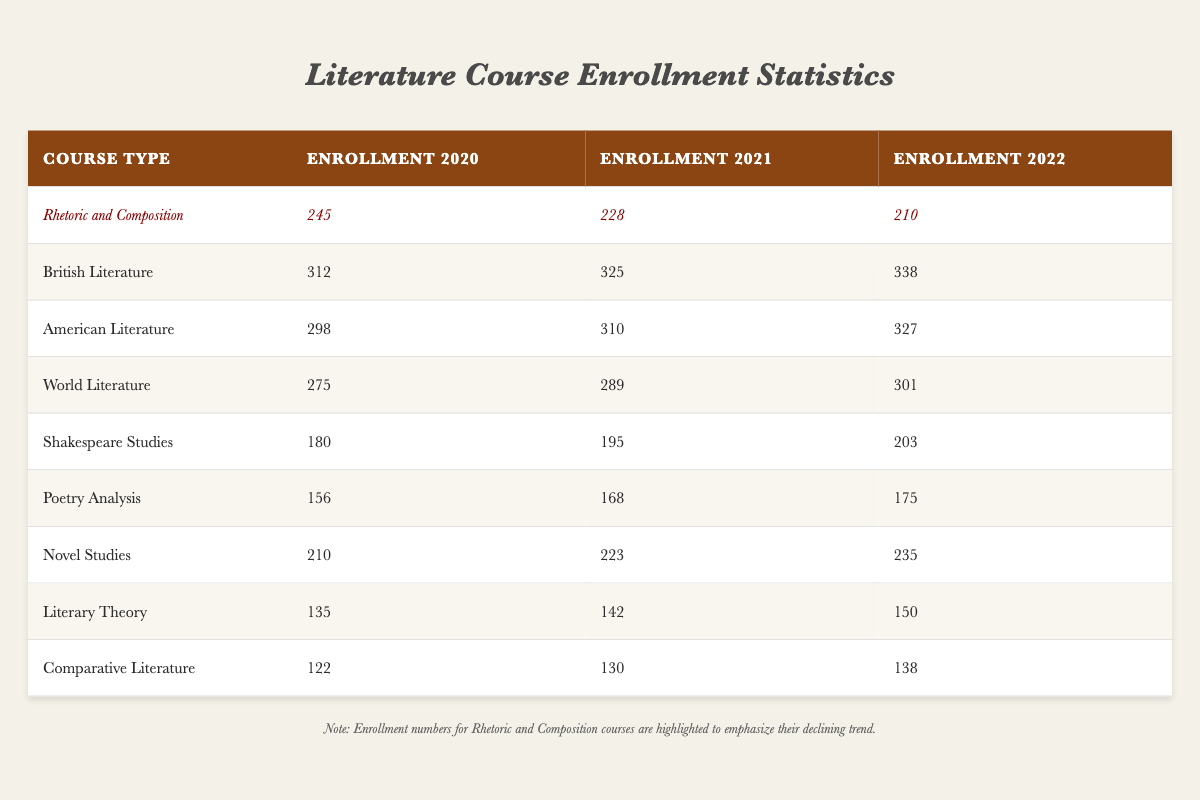What was the enrollment for Rhetoric and Composition in 2021? The table shows that the enrollment for Rhetoric and Composition in 2021 is 228.
Answer: 228 Which literature course had the highest enrollment in 2022? In 2022, British Literature had the highest enrollment at 338, compared to other courses listed.
Answer: 338 What is the difference in enrollment between American Literature in 2020 and 2021? The enrollment for American Literature in 2020 was 298, and in 2021 it was 310. The difference is 310 - 298 = 12.
Answer: 12 Did enrollment for Rhetoric and Composition increase from 2020 to 2021? The enrollment numbers show Rhetoric and Composition decreased from 245 in 2020 to 228 in 2021, meaning it did not increase.
Answer: No What was the average enrollment for Shakespeare Studies over the three years? The enrollments for Shakespeare Studies are 180, 195, and 203. The average is (180 + 195 + 203) / 3 = 192.67.
Answer: 192.67 How many total students enrolled in Poetry Analysis from 2020 to 2022? To find the total, sum the enrollments for Poetry Analysis over the three years: 156 + 168 + 175 = 499.
Answer: 499 What percentage decrease did Rhetoric and Composition experience from 2020 to 2022? The enrollment dropped from 245 in 2020 to 210 in 2022. The decrease is 245 - 210 = 35. The percentage decrease is (35 / 245) * 100 = 14.29%.
Answer: 14.29% Which course type had a consistent increase in enrollment from 2020 to 2022? By examining the enrollments, British Literature shows an increase from 312 in 2020 to 338 in 2022. This consistency indicates growth throughout the years.
Answer: British Literature What was the total enrollment for all courses in 2021? To calculate the total enrollment for 2021, sum all the enrollments: 228 + 325 + 310 + 289 + 195 + 168 + 223 + 142 + 130 = 2010.
Answer: 2010 